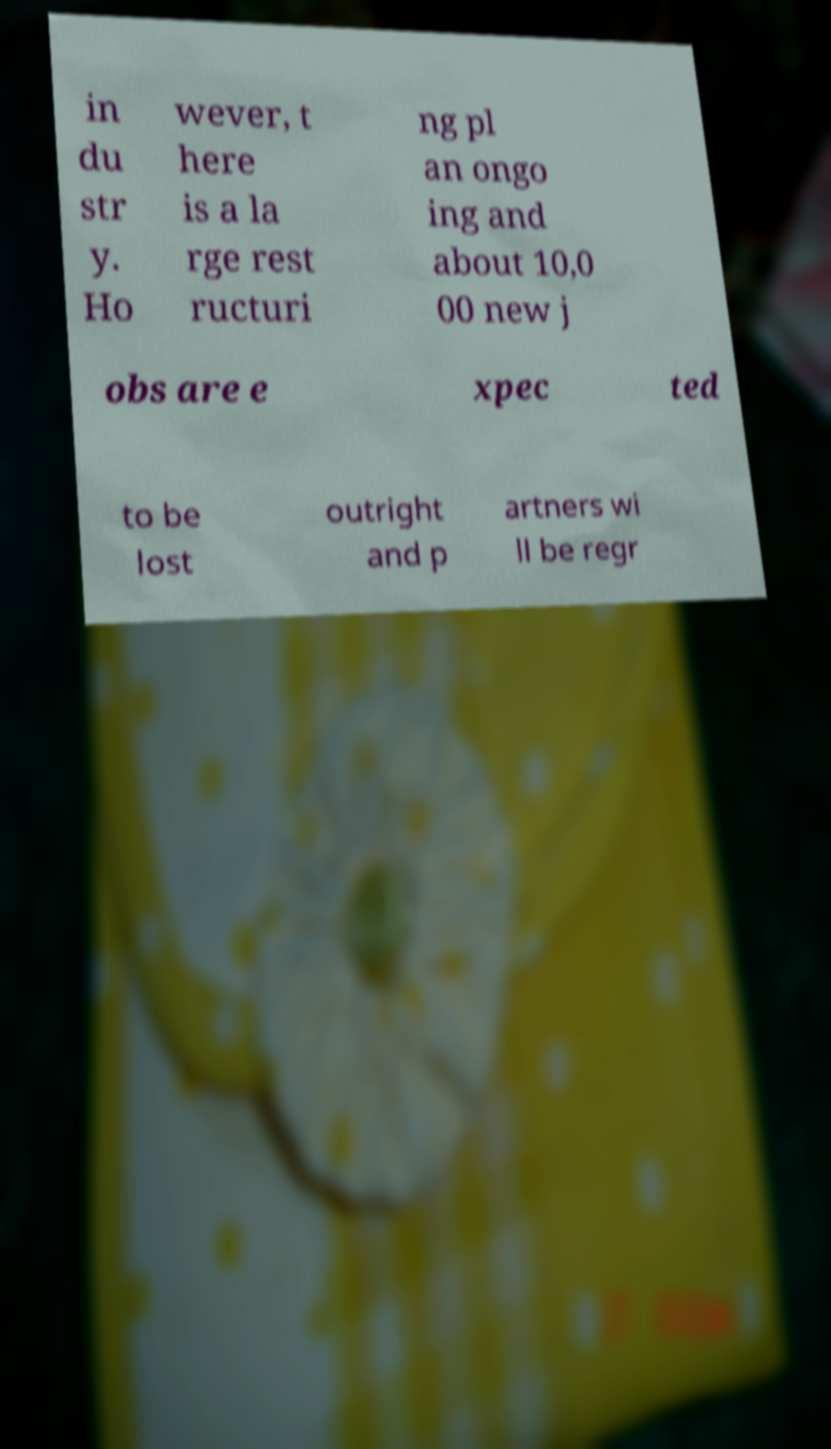Please identify and transcribe the text found in this image. in du str y. Ho wever, t here is a la rge rest ructuri ng pl an ongo ing and about 10,0 00 new j obs are e xpec ted to be lost outright and p artners wi ll be regr 